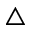<formula> <loc_0><loc_0><loc_500><loc_500>\bigtriangleup</formula> 